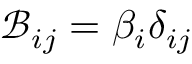<formula> <loc_0><loc_0><loc_500><loc_500>\mathcal { B } _ { i j } = \beta _ { i } \delta _ { i j }</formula> 